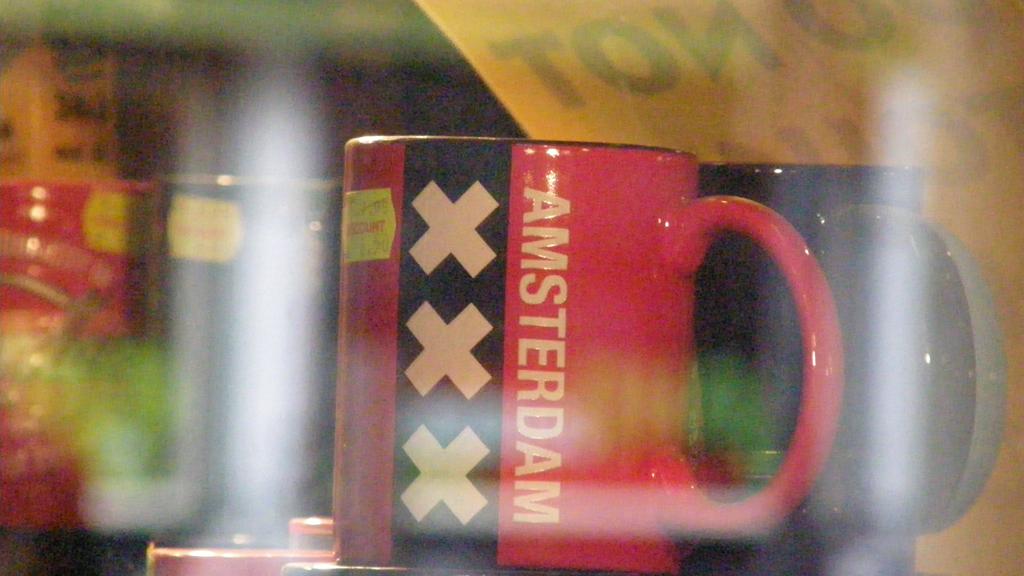What city is on the mug?
Ensure brevity in your answer.  Amsterdam. Can you the price on the mug?
Provide a succinct answer. No. 